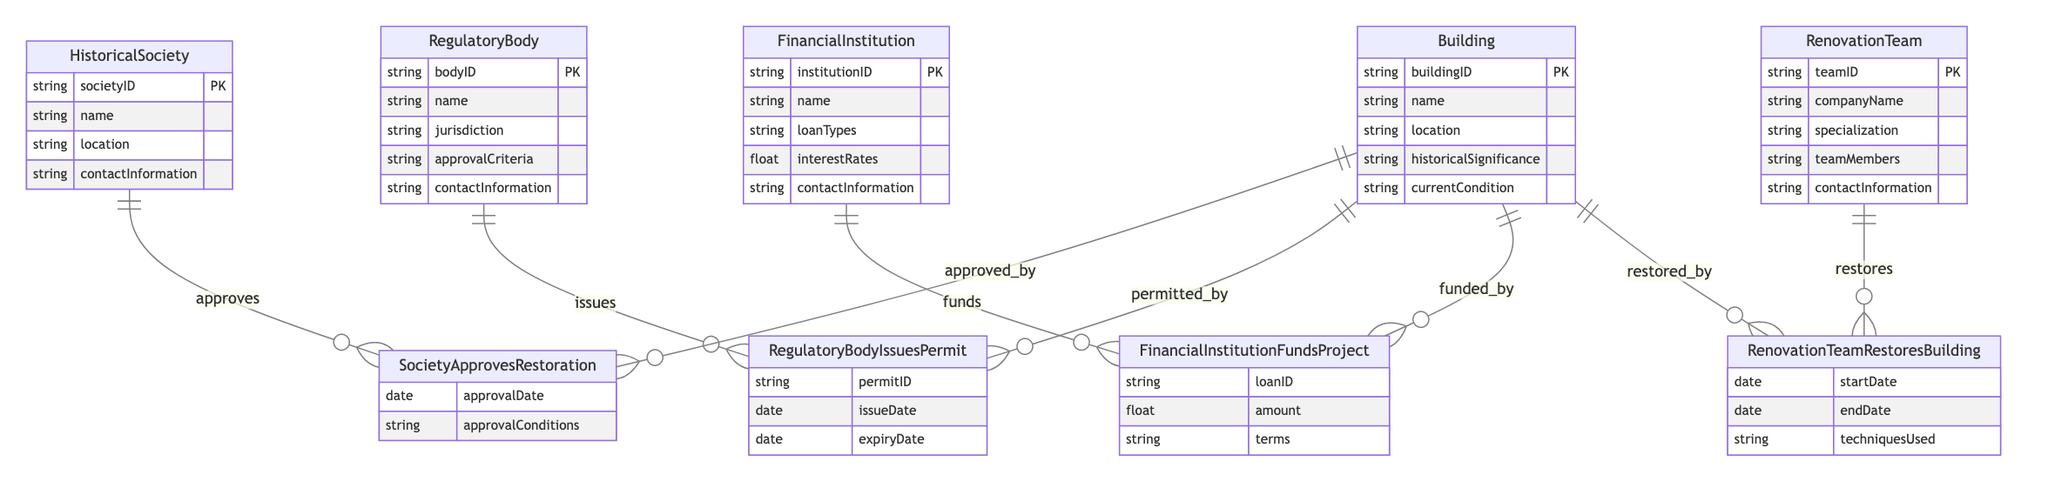What is the primary purpose of the Historical Society? The primary purpose of the Historical Society is to approve restorations of buildings. This is evident from the relationship "SocietyApprovesRestoration," which indicates that the Historical Society plays a critical role in the restoration process.
Answer: approve restorations How many entities are involved in the funding process? There are two entities involved in the funding process: FinancialInstitution and Building. The relationship "FinancialInstitutionFundsProject" directly connects these two entities, indicating their involvement in funding projects.
Answer: two What type of relationship exists between the Regulatory Body and the Building? The relationship between the Regulatory Body and the Building is one-to-many, as indicated by the relationship "RegulatoryBodyIssuesPermit." This means a single regulatory body can issue permits for multiple buildings.
Answer: one-to-many What additional information can be obtained when a Historical Society approves a restoration? When a Historical Society approves a restoration, the additional information includes the approval date and approval conditions, as provided by the attributes of the relationship "SocietyApprovesRestoration." This highlights what conditions must be met upon approval.
Answer: approval date, approval conditions How many techniques used are documented in the Renovation Team's relationship with buildings? The relationship "RenovationTeamRestoresBuilding" documents various techniques used in renovations. This attribute shows how renovation techniques are linked to specific teams and buildings, indicating a rich diversity in preservation methods.
Answer: techniques used Which entity is responsible for issuing permits? The entity responsible for issuing permits is the Regulatory Body, as shown through the relationship "RegulatoryBodyIssuesPermit," which clearly outlines their role in the permitting process for buildings.
Answer: Regulatory Body What feature distinguishes the Financial Institution in the diagram? The distinguishing feature of the Financial Institution in the diagram is its ability to fund projects, illustrated by the relationship "FinancialInstitutionFundsProject," which indicates their unique role in providing financial support for restoration.
Answer: funds projects In what scenario might a Renovation Team collaborate with a Historical Society? A Renovation Team might collaborate with a Historical Society when seeking approval for restoration projects. The relationship "SocietyApprovesRestoration" illustrates the potential need for teams to secure societal approval based on historical considerations.
Answer: seeking approval What is a unique feature of the building entity in relation to the other entities? A unique feature of the Building entity is that it serves as a central point that connects to all other entities (HistoricalSociety, RegulatoryBody, FinancialInstitution, and RenovationTeam), emphasizing its importance in the overall preservation process.
Answer: central point 